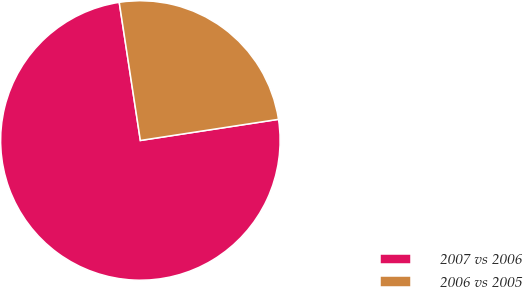Convert chart. <chart><loc_0><loc_0><loc_500><loc_500><pie_chart><fcel>2007 vs 2006<fcel>2006 vs 2005<nl><fcel>75.0%<fcel>25.0%<nl></chart> 